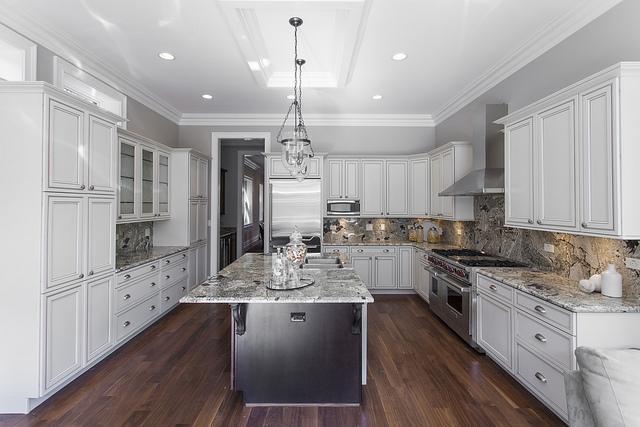How many couches can you see?
Give a very brief answer. 1. 